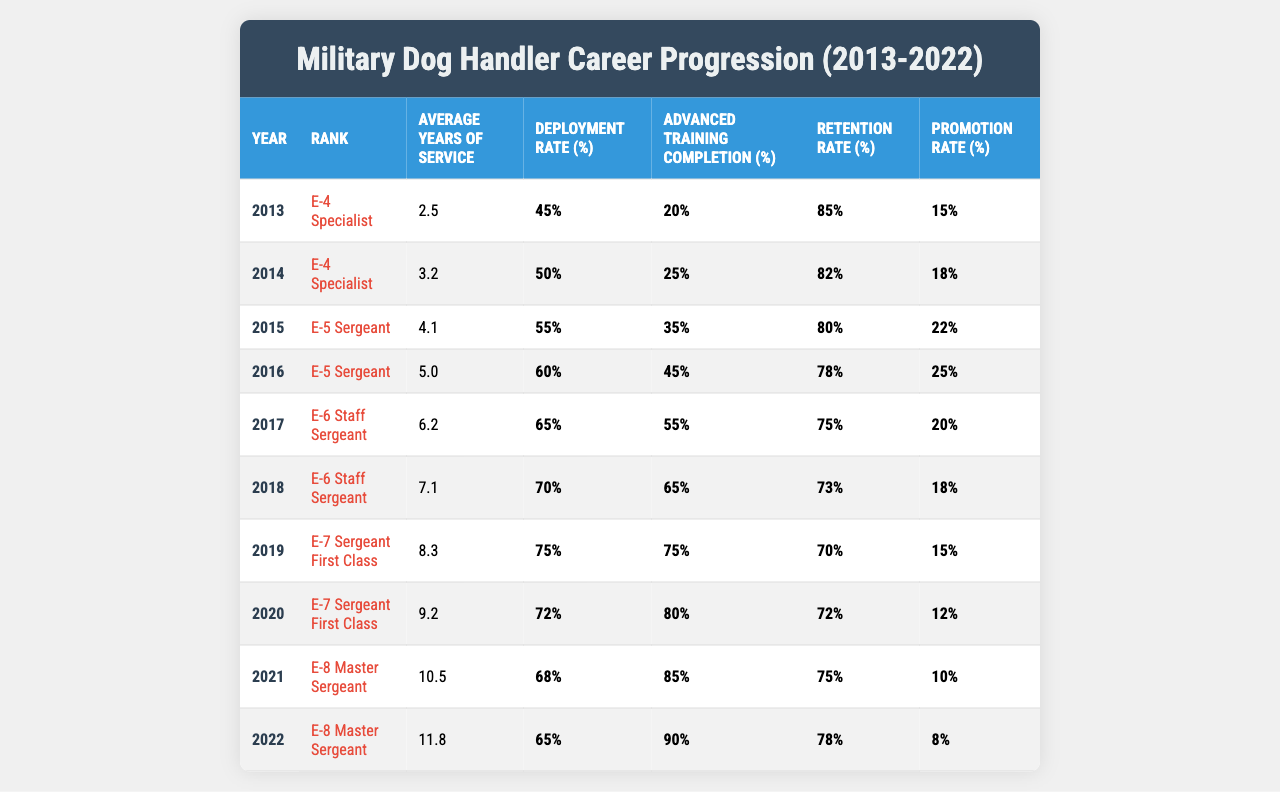What is the average years of service for military dog handlers in 2015? In 2015, the average years of service listed in the table is 4.1 years for military dog handlers.
Answer: 4.1 years What percentage of military dog handlers completed advanced training in 2020? The advanced training completion percentage for 2020 is 80%, as stated in the table.
Answer: 80% What was the promotion rate for military dog handlers in 2019? The promotion rate for military dog handlers in 2019 is 15%, which can be found in the respective row of the table.
Answer: 15% Which year saw the highest deployment rate for military dog handlers, and what was that rate? The highest deployment rate occurred in 2019, with a percentage of 75%.
Answer: 2019, 75% In which year did the average years of service first exceed 10 years? The average years of service first exceeded 10 years in 2021, reaching 10.5 years.
Answer: 2021 What is the difference between the retention rates in 2013 and 2022? The retention rate in 2013 is 85% and in 2022 it is 78%. Thus, the difference is 85% - 78% = 7%.
Answer: 7% What is the average promotion rate over the ten years from 2013 to 2022? To calculate the average promotion rate, we sum the promotion rates (15 + 18 + 22 + 25 + 20 + 18 + 15 + 12 + 10 + 8) = 153 and divide by 10 (number of years), which gives us an average of 15.3%.
Answer: 15.3% Did the retention rate for military dog handlers increase or decrease from 2015 to 2022? The retention rate in 2015 was 80%, and by 2022 it decreased to 78%. Therefore, it decreased.
Answer: Decreased What was the trend in advanced training completion rates from 2013 to 2022? The advanced training completion rates increased from 20% in 2013 to 90% in 2022. Thus, the trend shows a consistent increase in advanced training completion rates over the years.
Answer: Increased Which rank had the highest average years of service and what was that average? The rank with the highest average years of service is E-8 Master Sergeant in 2022, with an average of 11.8 years.
Answer: E-8 Master Sergeant, 11.8 years 